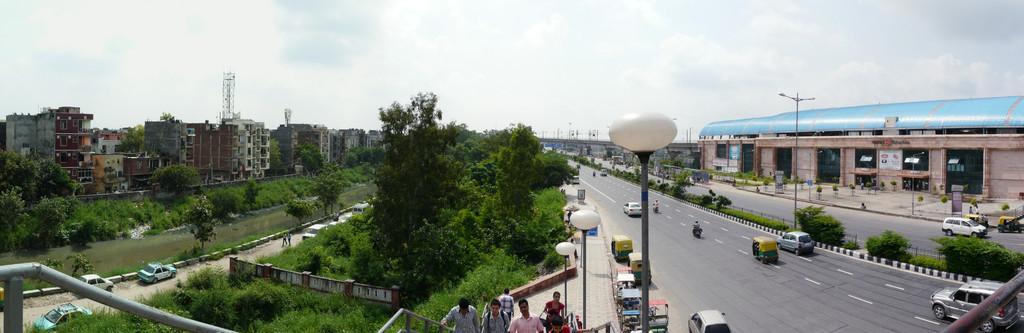Describe this image in one or two sentences. In this image, we can see so many buildings, trees, plants, poles, lights and few people. Here there are few vehicles on the road. Top of the image, we can see the sky. 